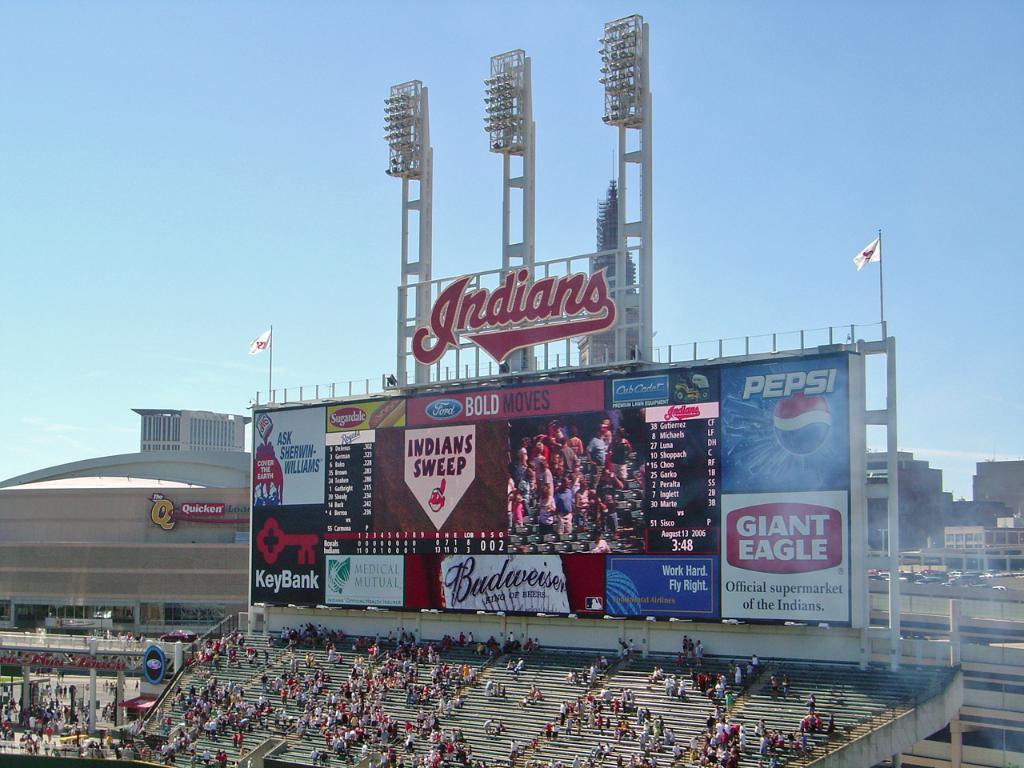<image>
Relay a brief, clear account of the picture shown. The inside of the Indians arena showcasing the scoreboard with Pepsi advertising on it. 